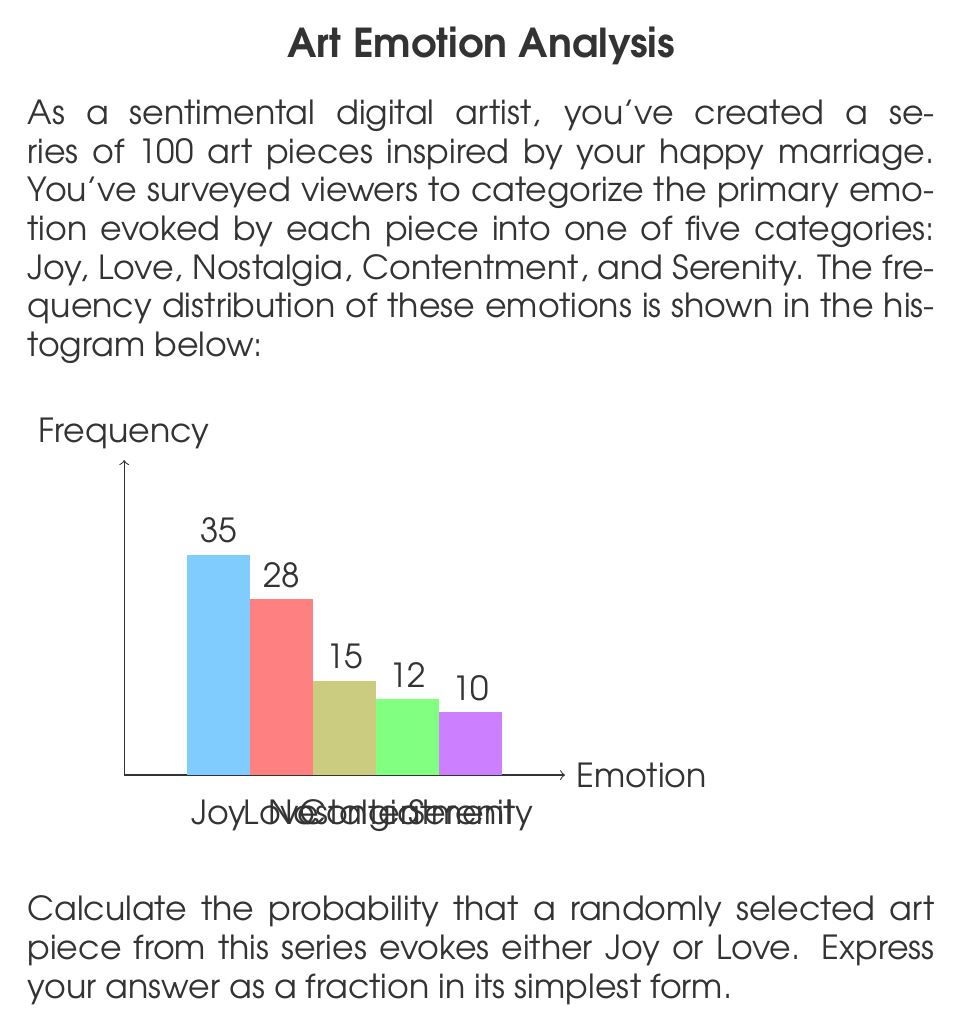Provide a solution to this math problem. To solve this problem, we'll follow these steps:

1) First, let's identify the total number of art pieces and the number of pieces evoking Joy or Love.

   Total art pieces = 100 (given in the question)
   Pieces evoking Joy = 35
   Pieces evoking Love = 28

2) To find the probability, we need to calculate:

   $$ P(\text{Joy or Love}) = \frac{\text{Number of favorable outcomes}}{\text{Total number of possible outcomes}} $$

3) In this case:
   - Favorable outcomes = Pieces evoking Joy + Pieces evoking Love
   - Total possible outcomes = Total art pieces

4) Let's plug in the numbers:

   $$ P(\text{Joy or Love}) = \frac{35 + 28}{100} = \frac{63}{100} $$

5) This fraction can be simplified by dividing both numerator and denominator by their greatest common divisor (GCD). The GCD of 63 and 100 is 1, so this fraction is already in its simplest form.

Therefore, the probability that a randomly selected art piece evokes either Joy or Love is $\frac{63}{100}$.
Answer: $\frac{63}{100}$ 